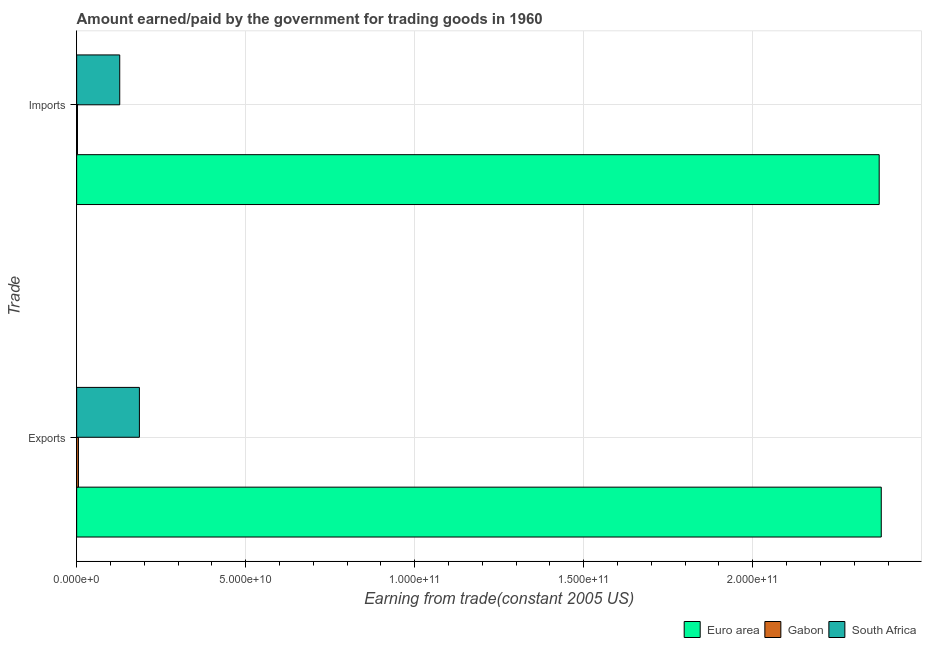How many different coloured bars are there?
Make the answer very short. 3. How many groups of bars are there?
Offer a terse response. 2. Are the number of bars per tick equal to the number of legend labels?
Keep it short and to the point. Yes. Are the number of bars on each tick of the Y-axis equal?
Your response must be concise. Yes. How many bars are there on the 1st tick from the bottom?
Ensure brevity in your answer.  3. What is the label of the 1st group of bars from the top?
Provide a succinct answer. Imports. What is the amount paid for imports in Euro area?
Your response must be concise. 2.37e+11. Across all countries, what is the maximum amount paid for imports?
Your answer should be very brief. 2.37e+11. Across all countries, what is the minimum amount earned from exports?
Provide a succinct answer. 5.28e+08. In which country was the amount paid for imports maximum?
Offer a very short reply. Euro area. In which country was the amount earned from exports minimum?
Provide a succinct answer. Gabon. What is the total amount earned from exports in the graph?
Give a very brief answer. 2.57e+11. What is the difference between the amount earned from exports in Euro area and that in Gabon?
Keep it short and to the point. 2.37e+11. What is the difference between the amount earned from exports in Gabon and the amount paid for imports in Euro area?
Provide a short and direct response. -2.37e+11. What is the average amount paid for imports per country?
Make the answer very short. 8.35e+1. What is the difference between the amount paid for imports and amount earned from exports in South Africa?
Keep it short and to the point. -5.82e+09. In how many countries, is the amount earned from exports greater than 230000000000 US$?
Your answer should be compact. 1. What is the ratio of the amount earned from exports in Gabon to that in South Africa?
Your answer should be very brief. 0.03. Is the amount paid for imports in South Africa less than that in Gabon?
Give a very brief answer. No. In how many countries, is the amount earned from exports greater than the average amount earned from exports taken over all countries?
Your answer should be very brief. 1. What does the 2nd bar from the top in Imports represents?
Offer a terse response. Gabon. What does the 2nd bar from the bottom in Imports represents?
Provide a short and direct response. Gabon. How many countries are there in the graph?
Offer a terse response. 3. What is the difference between two consecutive major ticks on the X-axis?
Your answer should be very brief. 5.00e+1. Does the graph contain any zero values?
Give a very brief answer. No. Does the graph contain grids?
Keep it short and to the point. Yes. Where does the legend appear in the graph?
Your answer should be very brief. Bottom right. How many legend labels are there?
Your response must be concise. 3. How are the legend labels stacked?
Your response must be concise. Horizontal. What is the title of the graph?
Provide a succinct answer. Amount earned/paid by the government for trading goods in 1960. What is the label or title of the X-axis?
Give a very brief answer. Earning from trade(constant 2005 US). What is the label or title of the Y-axis?
Ensure brevity in your answer.  Trade. What is the Earning from trade(constant 2005 US) of Euro area in Exports?
Provide a succinct answer. 2.38e+11. What is the Earning from trade(constant 2005 US) of Gabon in Exports?
Give a very brief answer. 5.28e+08. What is the Earning from trade(constant 2005 US) in South Africa in Exports?
Make the answer very short. 1.86e+1. What is the Earning from trade(constant 2005 US) in Euro area in Imports?
Offer a terse response. 2.37e+11. What is the Earning from trade(constant 2005 US) of Gabon in Imports?
Give a very brief answer. 2.44e+08. What is the Earning from trade(constant 2005 US) in South Africa in Imports?
Offer a very short reply. 1.27e+1. Across all Trade, what is the maximum Earning from trade(constant 2005 US) in Euro area?
Keep it short and to the point. 2.38e+11. Across all Trade, what is the maximum Earning from trade(constant 2005 US) of Gabon?
Give a very brief answer. 5.28e+08. Across all Trade, what is the maximum Earning from trade(constant 2005 US) of South Africa?
Provide a succinct answer. 1.86e+1. Across all Trade, what is the minimum Earning from trade(constant 2005 US) of Euro area?
Offer a very short reply. 2.37e+11. Across all Trade, what is the minimum Earning from trade(constant 2005 US) in Gabon?
Ensure brevity in your answer.  2.44e+08. Across all Trade, what is the minimum Earning from trade(constant 2005 US) in South Africa?
Your answer should be compact. 1.27e+1. What is the total Earning from trade(constant 2005 US) of Euro area in the graph?
Your answer should be very brief. 4.75e+11. What is the total Earning from trade(constant 2005 US) of Gabon in the graph?
Your answer should be very brief. 7.72e+08. What is the total Earning from trade(constant 2005 US) of South Africa in the graph?
Your response must be concise. 3.13e+1. What is the difference between the Earning from trade(constant 2005 US) in Euro area in Exports and that in Imports?
Provide a succinct answer. 6.14e+08. What is the difference between the Earning from trade(constant 2005 US) of Gabon in Exports and that in Imports?
Offer a very short reply. 2.85e+08. What is the difference between the Earning from trade(constant 2005 US) of South Africa in Exports and that in Imports?
Provide a short and direct response. 5.82e+09. What is the difference between the Earning from trade(constant 2005 US) in Euro area in Exports and the Earning from trade(constant 2005 US) in Gabon in Imports?
Keep it short and to the point. 2.38e+11. What is the difference between the Earning from trade(constant 2005 US) in Euro area in Exports and the Earning from trade(constant 2005 US) in South Africa in Imports?
Give a very brief answer. 2.25e+11. What is the difference between the Earning from trade(constant 2005 US) of Gabon in Exports and the Earning from trade(constant 2005 US) of South Africa in Imports?
Offer a very short reply. -1.22e+1. What is the average Earning from trade(constant 2005 US) in Euro area per Trade?
Offer a terse response. 2.38e+11. What is the average Earning from trade(constant 2005 US) of Gabon per Trade?
Give a very brief answer. 3.86e+08. What is the average Earning from trade(constant 2005 US) of South Africa per Trade?
Your answer should be very brief. 1.56e+1. What is the difference between the Earning from trade(constant 2005 US) in Euro area and Earning from trade(constant 2005 US) in Gabon in Exports?
Offer a very short reply. 2.37e+11. What is the difference between the Earning from trade(constant 2005 US) of Euro area and Earning from trade(constant 2005 US) of South Africa in Exports?
Ensure brevity in your answer.  2.19e+11. What is the difference between the Earning from trade(constant 2005 US) of Gabon and Earning from trade(constant 2005 US) of South Africa in Exports?
Your answer should be very brief. -1.80e+1. What is the difference between the Earning from trade(constant 2005 US) in Euro area and Earning from trade(constant 2005 US) in Gabon in Imports?
Your response must be concise. 2.37e+11. What is the difference between the Earning from trade(constant 2005 US) in Euro area and Earning from trade(constant 2005 US) in South Africa in Imports?
Provide a short and direct response. 2.25e+11. What is the difference between the Earning from trade(constant 2005 US) in Gabon and Earning from trade(constant 2005 US) in South Africa in Imports?
Make the answer very short. -1.25e+1. What is the ratio of the Earning from trade(constant 2005 US) of Euro area in Exports to that in Imports?
Your response must be concise. 1. What is the ratio of the Earning from trade(constant 2005 US) of Gabon in Exports to that in Imports?
Make the answer very short. 2.17. What is the ratio of the Earning from trade(constant 2005 US) in South Africa in Exports to that in Imports?
Your response must be concise. 1.46. What is the difference between the highest and the second highest Earning from trade(constant 2005 US) in Euro area?
Offer a terse response. 6.14e+08. What is the difference between the highest and the second highest Earning from trade(constant 2005 US) in Gabon?
Ensure brevity in your answer.  2.85e+08. What is the difference between the highest and the second highest Earning from trade(constant 2005 US) of South Africa?
Provide a short and direct response. 5.82e+09. What is the difference between the highest and the lowest Earning from trade(constant 2005 US) of Euro area?
Your answer should be very brief. 6.14e+08. What is the difference between the highest and the lowest Earning from trade(constant 2005 US) of Gabon?
Ensure brevity in your answer.  2.85e+08. What is the difference between the highest and the lowest Earning from trade(constant 2005 US) in South Africa?
Make the answer very short. 5.82e+09. 